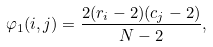<formula> <loc_0><loc_0><loc_500><loc_500>\varphi _ { 1 } ( i , j ) = \frac { 2 ( r _ { i } - 2 ) ( c _ { j } - 2 ) } { N - 2 } ,</formula> 